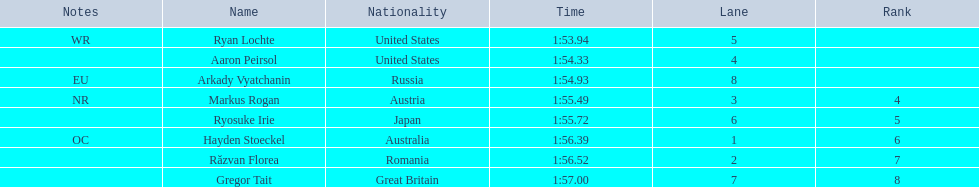How long did it take ryosuke irie to finish? 1:55.72. 